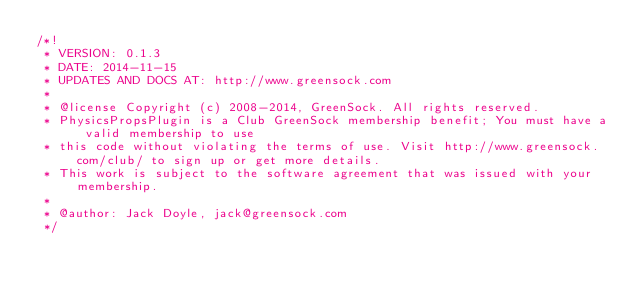Convert code to text. <code><loc_0><loc_0><loc_500><loc_500><_JavaScript_>/*!
 * VERSION: 0.1.3
 * DATE: 2014-11-15
 * UPDATES AND DOCS AT: http://www.greensock.com
 *
 * @license Copyright (c) 2008-2014, GreenSock. All rights reserved.
 * PhysicsPropsPlugin is a Club GreenSock membership benefit; You must have a valid membership to use
 * this code without violating the terms of use. Visit http://www.greensock.com/club/ to sign up or get more details.
 * This work is subject to the software agreement that was issued with your membership.
 * 
 * @author: Jack Doyle, jack@greensock.com
 */</code> 